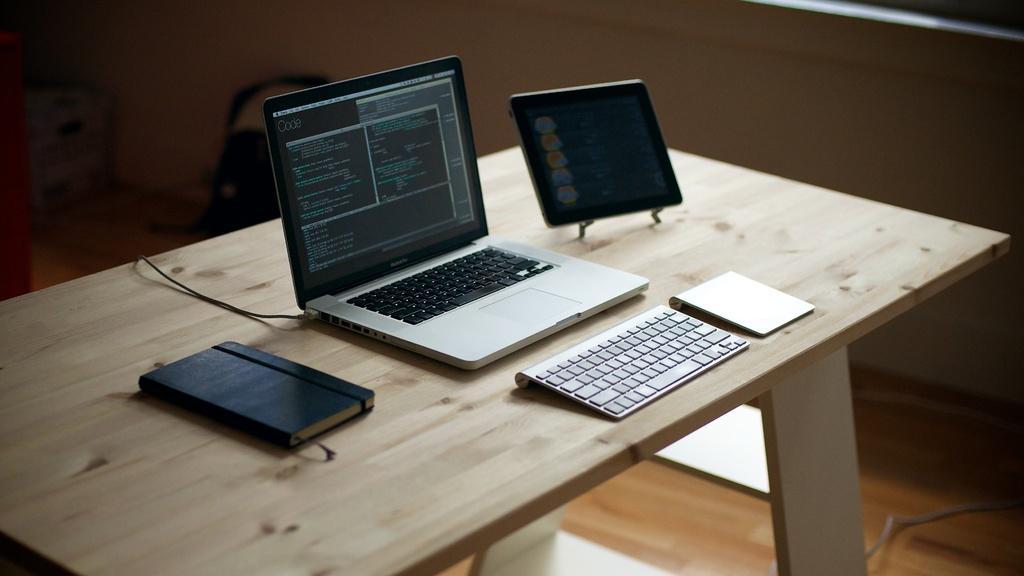Can you describe this image briefly? In this picture there is a table on which a laptop, keyboard, ipad and a diary was placed. In the background there is a wall. 